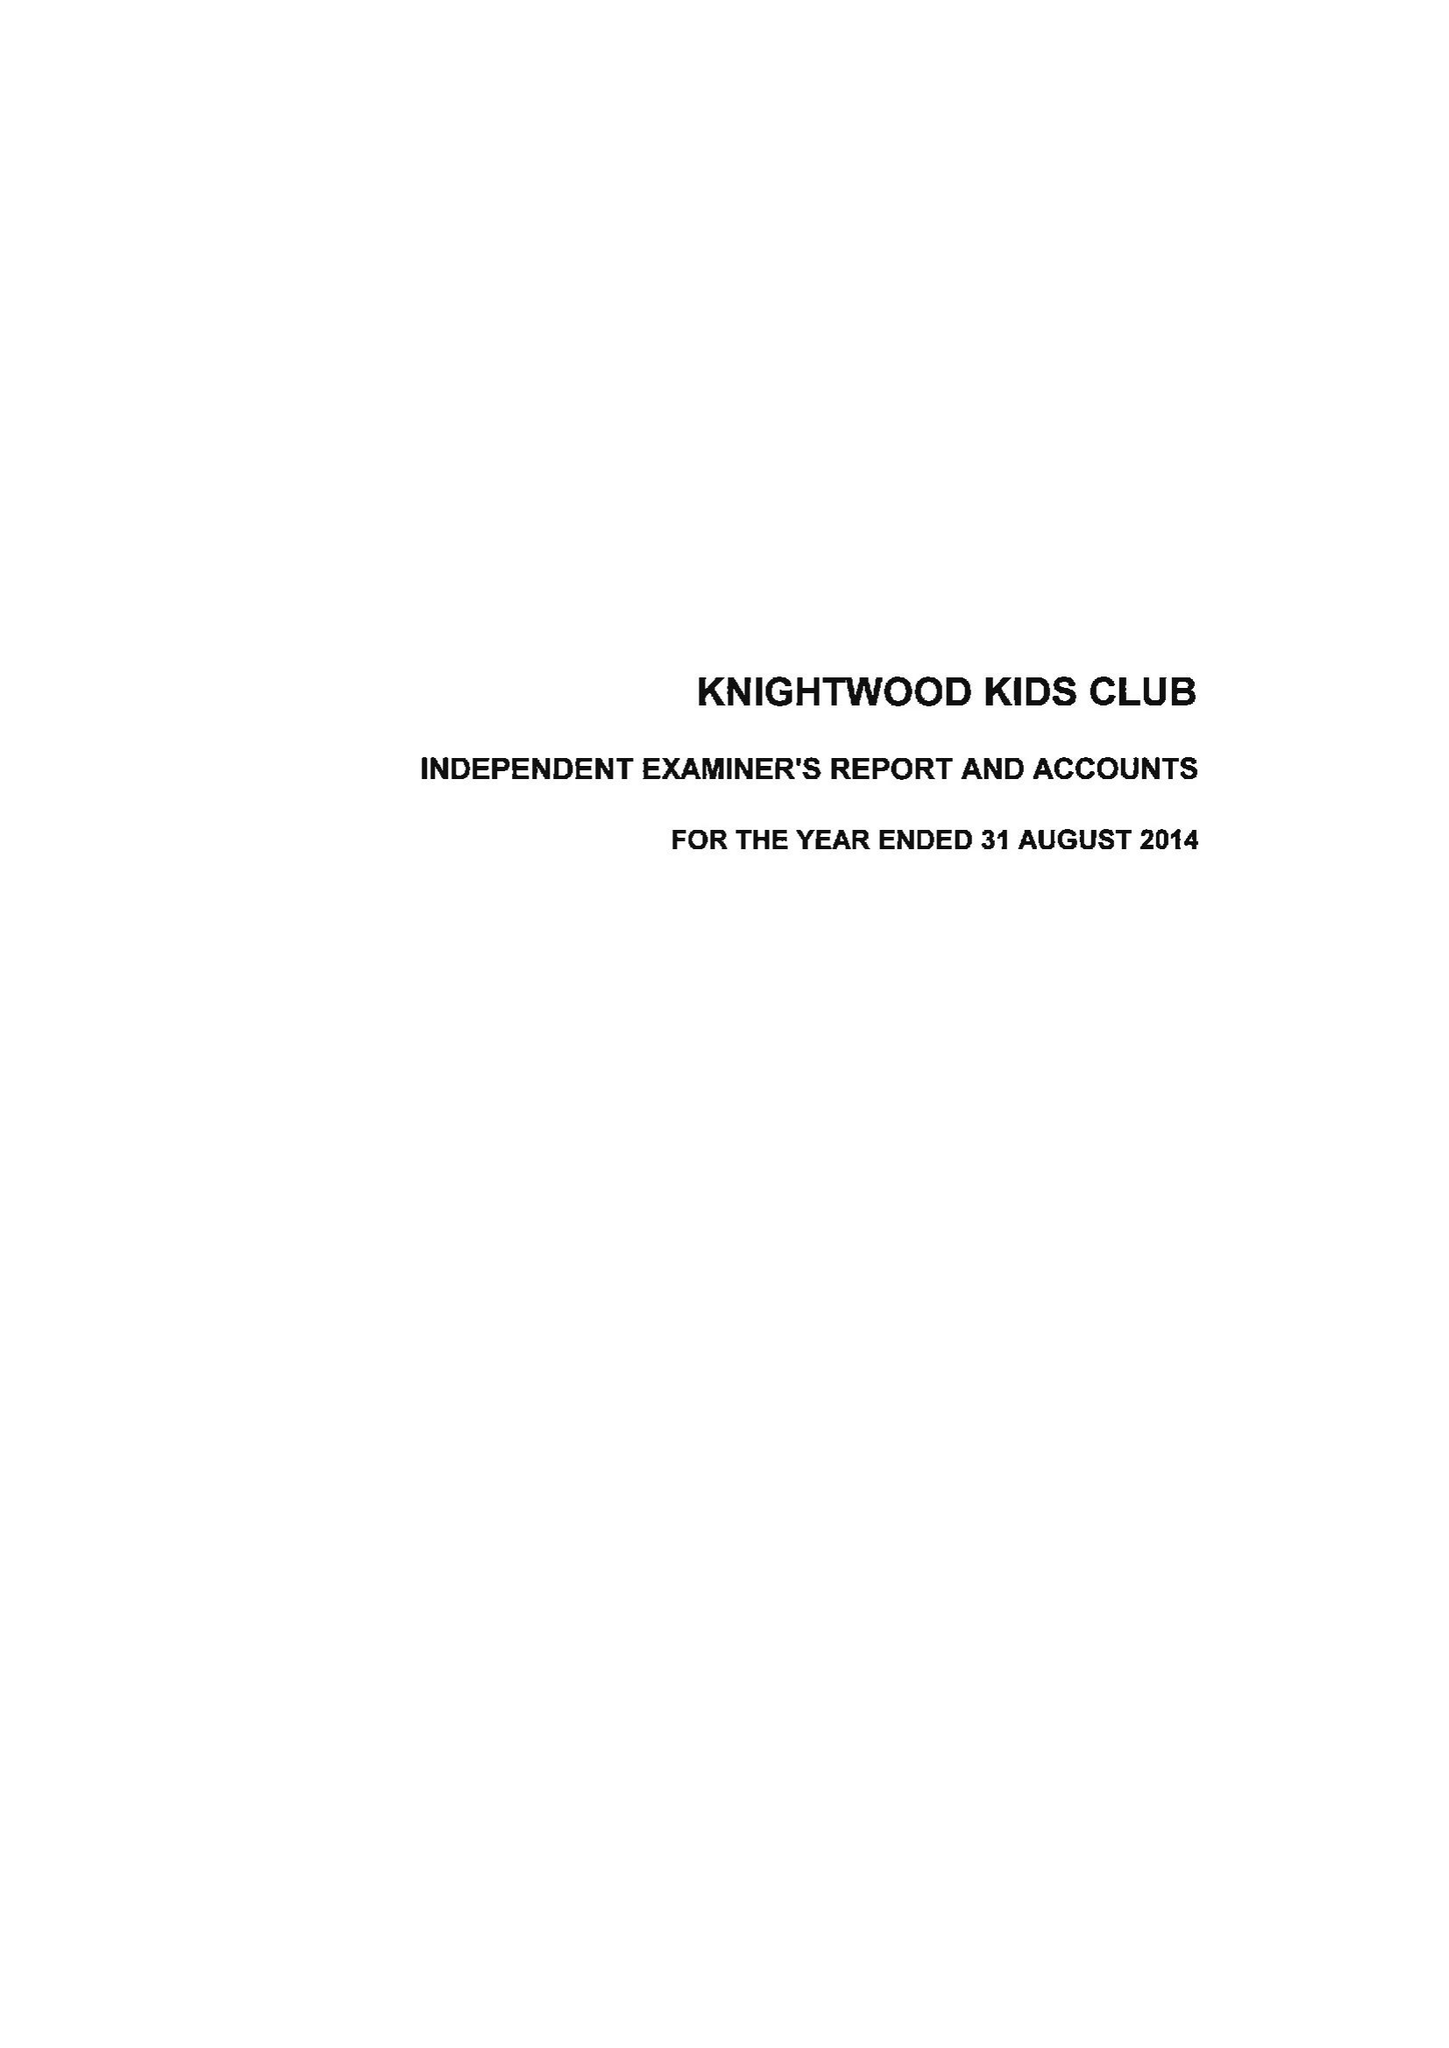What is the value for the address__post_town?
Answer the question using a single word or phrase. SOUTHAMPTON 